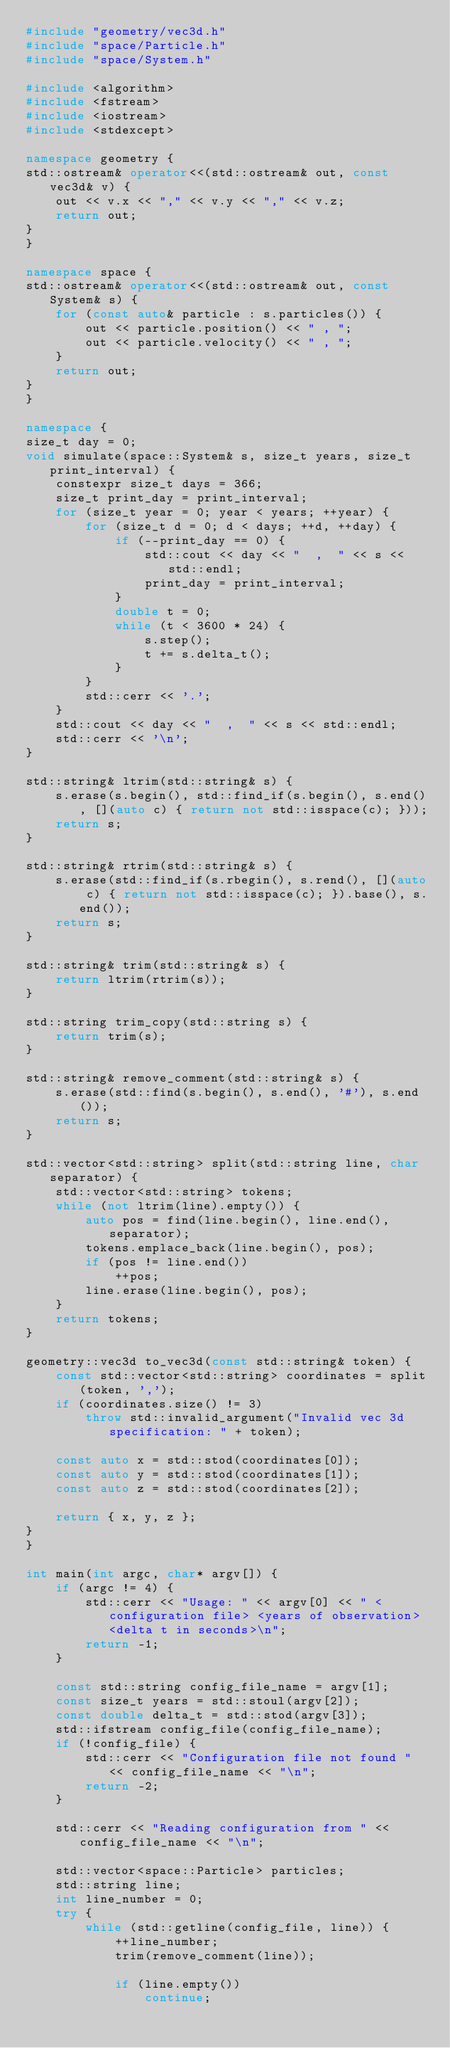Convert code to text. <code><loc_0><loc_0><loc_500><loc_500><_C++_>#include "geometry/vec3d.h"
#include "space/Particle.h"
#include "space/System.h"

#include <algorithm>
#include <fstream>
#include <iostream>
#include <stdexcept>

namespace geometry {
std::ostream& operator<<(std::ostream& out, const vec3d& v) {
    out << v.x << "," << v.y << "," << v.z;
    return out;
}
}

namespace space {
std::ostream& operator<<(std::ostream& out, const System& s) {
    for (const auto& particle : s.particles()) {
        out << particle.position() << " , ";
        out << particle.velocity() << " , ";
    }
    return out;
}
}

namespace {
size_t day = 0;
void simulate(space::System& s, size_t years, size_t print_interval) {
    constexpr size_t days = 366;
    size_t print_day = print_interval;
    for (size_t year = 0; year < years; ++year) {
        for (size_t d = 0; d < days; ++d, ++day) {
            if (--print_day == 0) {
                std::cout << day << "  ,  " << s << std::endl;
                print_day = print_interval;
            }
            double t = 0;
            while (t < 3600 * 24) {
                s.step();
                t += s.delta_t();
            }
        }
        std::cerr << '.';
    }
    std::cout << day << "  ,  " << s << std::endl;
    std::cerr << '\n';
}

std::string& ltrim(std::string& s) {
    s.erase(s.begin(), std::find_if(s.begin(), s.end(), [](auto c) { return not std::isspace(c); }));
    return s;
}

std::string& rtrim(std::string& s) {
    s.erase(std::find_if(s.rbegin(), s.rend(), [](auto c) { return not std::isspace(c); }).base(), s.end());
    return s;
}

std::string& trim(std::string& s) {
    return ltrim(rtrim(s));
}

std::string trim_copy(std::string s) {
    return trim(s);
}

std::string& remove_comment(std::string& s) {
    s.erase(std::find(s.begin(), s.end(), '#'), s.end());
    return s;
}

std::vector<std::string> split(std::string line, char separator) {
    std::vector<std::string> tokens;
    while (not ltrim(line).empty()) {
        auto pos = find(line.begin(), line.end(), separator);
        tokens.emplace_back(line.begin(), pos);
        if (pos != line.end())
            ++pos;
        line.erase(line.begin(), pos);
    }
    return tokens;
}

geometry::vec3d to_vec3d(const std::string& token) {
    const std::vector<std::string> coordinates = split(token, ',');
    if (coordinates.size() != 3)
        throw std::invalid_argument("Invalid vec 3d specification: " + token);

    const auto x = std::stod(coordinates[0]);
    const auto y = std::stod(coordinates[1]);
    const auto z = std::stod(coordinates[2]);

    return { x, y, z };
}
}

int main(int argc, char* argv[]) {
    if (argc != 4) {
        std::cerr << "Usage: " << argv[0] << " <configuration file> <years of observation> <delta t in seconds>\n";
        return -1;
    }

    const std::string config_file_name = argv[1];
    const size_t years = std::stoul(argv[2]);
    const double delta_t = std::stod(argv[3]);
    std::ifstream config_file(config_file_name);
    if (!config_file) {
        std::cerr << "Configuration file not found " << config_file_name << "\n";
        return -2;
    }

    std::cerr << "Reading configuration from " << config_file_name << "\n";

    std::vector<space::Particle> particles;
    std::string line;
    int line_number = 0;
    try {
        while (std::getline(config_file, line)) {
            ++line_number;
            trim(remove_comment(line));

            if (line.empty())
                continue;
</code> 